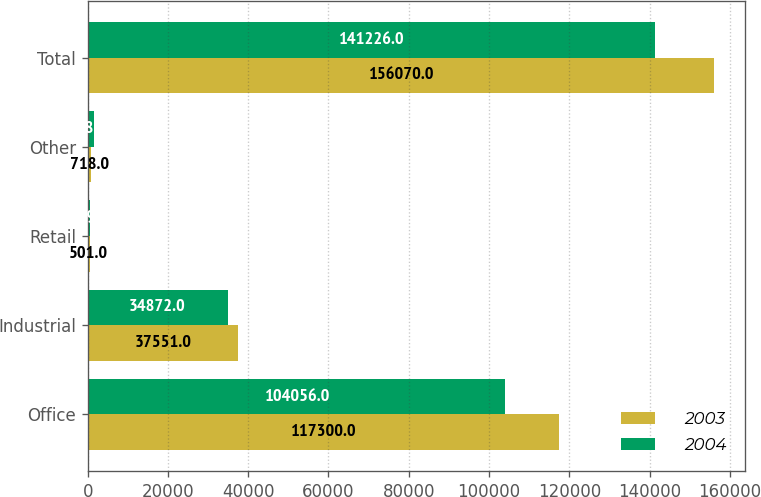Convert chart to OTSL. <chart><loc_0><loc_0><loc_500><loc_500><stacked_bar_chart><ecel><fcel>Office<fcel>Industrial<fcel>Retail<fcel>Other<fcel>Total<nl><fcel>2003<fcel>117300<fcel>37551<fcel>501<fcel>718<fcel>156070<nl><fcel>2004<fcel>104056<fcel>34872<fcel>609<fcel>1689<fcel>141226<nl></chart> 